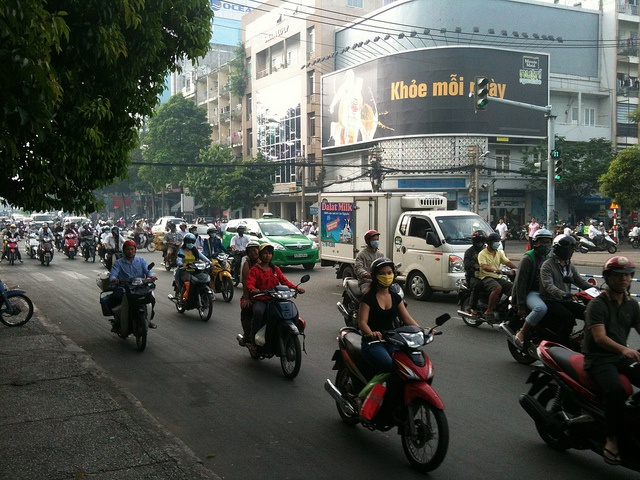Describe the objects in this image and their specific colors. I can see motorcycle in black, gray, darkgray, and white tones, people in black, gray, darkgray, and lightgray tones, truck in black, darkgray, gray, and lightgray tones, motorcycle in black, maroon, gray, and darkgray tones, and people in black, gray, maroon, and darkgray tones in this image. 